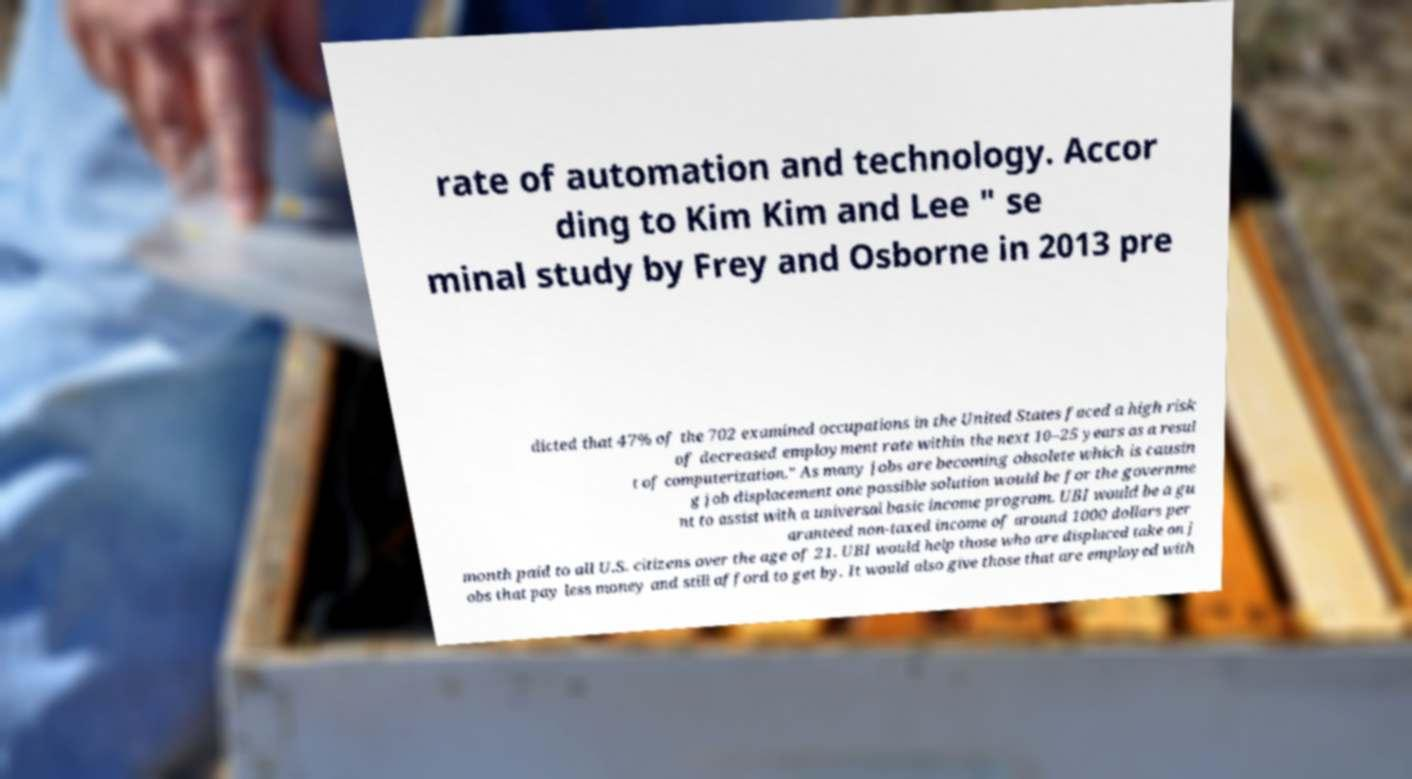Can you read and provide the text displayed in the image?This photo seems to have some interesting text. Can you extract and type it out for me? rate of automation and technology. Accor ding to Kim Kim and Lee " se minal study by Frey and Osborne in 2013 pre dicted that 47% of the 702 examined occupations in the United States faced a high risk of decreased employment rate within the next 10–25 years as a resul t of computerization." As many jobs are becoming obsolete which is causin g job displacement one possible solution would be for the governme nt to assist with a universal basic income program. UBI would be a gu aranteed non-taxed income of around 1000 dollars per month paid to all U.S. citizens over the age of 21. UBI would help those who are displaced take on j obs that pay less money and still afford to get by. It would also give those that are employed with 